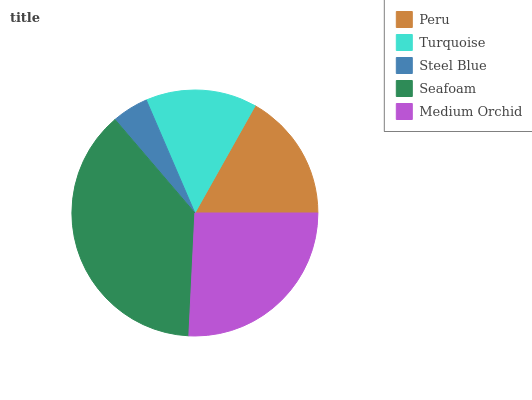Is Steel Blue the minimum?
Answer yes or no. Yes. Is Seafoam the maximum?
Answer yes or no. Yes. Is Turquoise the minimum?
Answer yes or no. No. Is Turquoise the maximum?
Answer yes or no. No. Is Peru greater than Turquoise?
Answer yes or no. Yes. Is Turquoise less than Peru?
Answer yes or no. Yes. Is Turquoise greater than Peru?
Answer yes or no. No. Is Peru less than Turquoise?
Answer yes or no. No. Is Peru the high median?
Answer yes or no. Yes. Is Peru the low median?
Answer yes or no. Yes. Is Turquoise the high median?
Answer yes or no. No. Is Seafoam the low median?
Answer yes or no. No. 